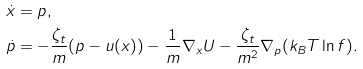<formula> <loc_0><loc_0><loc_500><loc_500>\dot { x } & = p , \\ \dot { p } & = - \frac { \zeta _ { t } } { m } ( p - u ( x ) ) - \frac { 1 } { m } \nabla _ { x } U - \frac { \zeta _ { t } } { m ^ { 2 } } \nabla _ { p } ( k _ { B } T \ln f ) .</formula> 